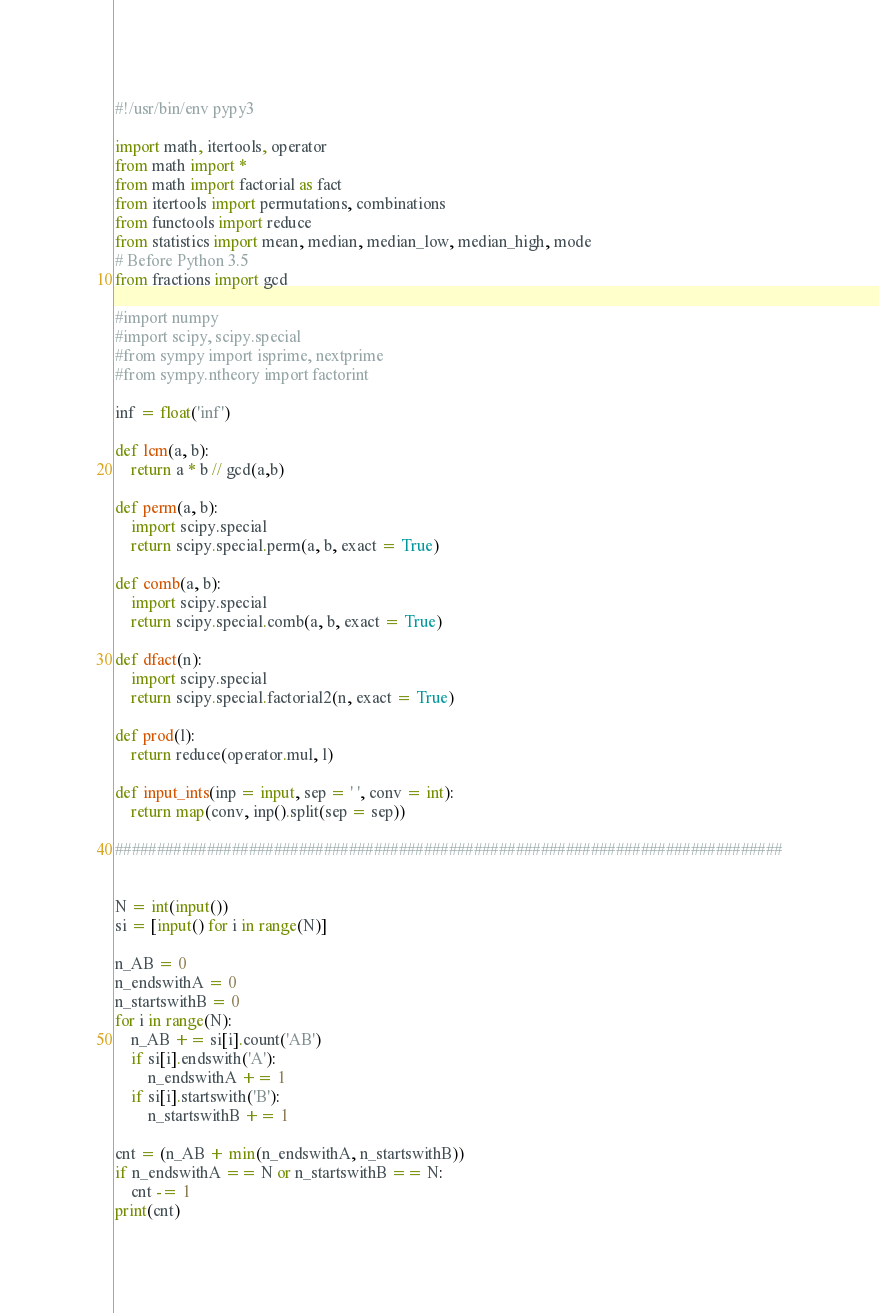<code> <loc_0><loc_0><loc_500><loc_500><_Python_>#!/usr/bin/env pypy3

import math, itertools, operator
from math import *
from math import factorial as fact
from itertools import permutations, combinations
from functools import reduce
from statistics import mean, median, median_low, median_high, mode
# Before Python 3.5
from fractions import gcd

#import numpy
#import scipy, scipy.special
#from sympy import isprime, nextprime
#from sympy.ntheory import factorint

inf = float('inf')

def lcm(a, b):
    return a * b // gcd(a,b)

def perm(a, b):
    import scipy.special
    return scipy.special.perm(a, b, exact = True)

def comb(a, b):
    import scipy.special
    return scipy.special.comb(a, b, exact = True)

def dfact(n):
    import scipy.special
    return scipy.special.factorial2(n, exact = True)

def prod(l):
    return reduce(operator.mul, l)

def input_ints(inp = input, sep = ' ', conv = int):
    return map(conv, inp().split(sep = sep))

################################################################################


N = int(input())
si = [input() for i in range(N)]

n_AB = 0
n_endswithA = 0
n_startswithB = 0
for i in range(N):
    n_AB += si[i].count('AB')
    if si[i].endswith('A'):
        n_endswithA += 1
    if si[i].startswith('B'):
        n_startswithB += 1

cnt = (n_AB + min(n_endswithA, n_startswithB))
if n_endswithA == N or n_startswithB == N:
    cnt -= 1
print(cnt)
</code> 